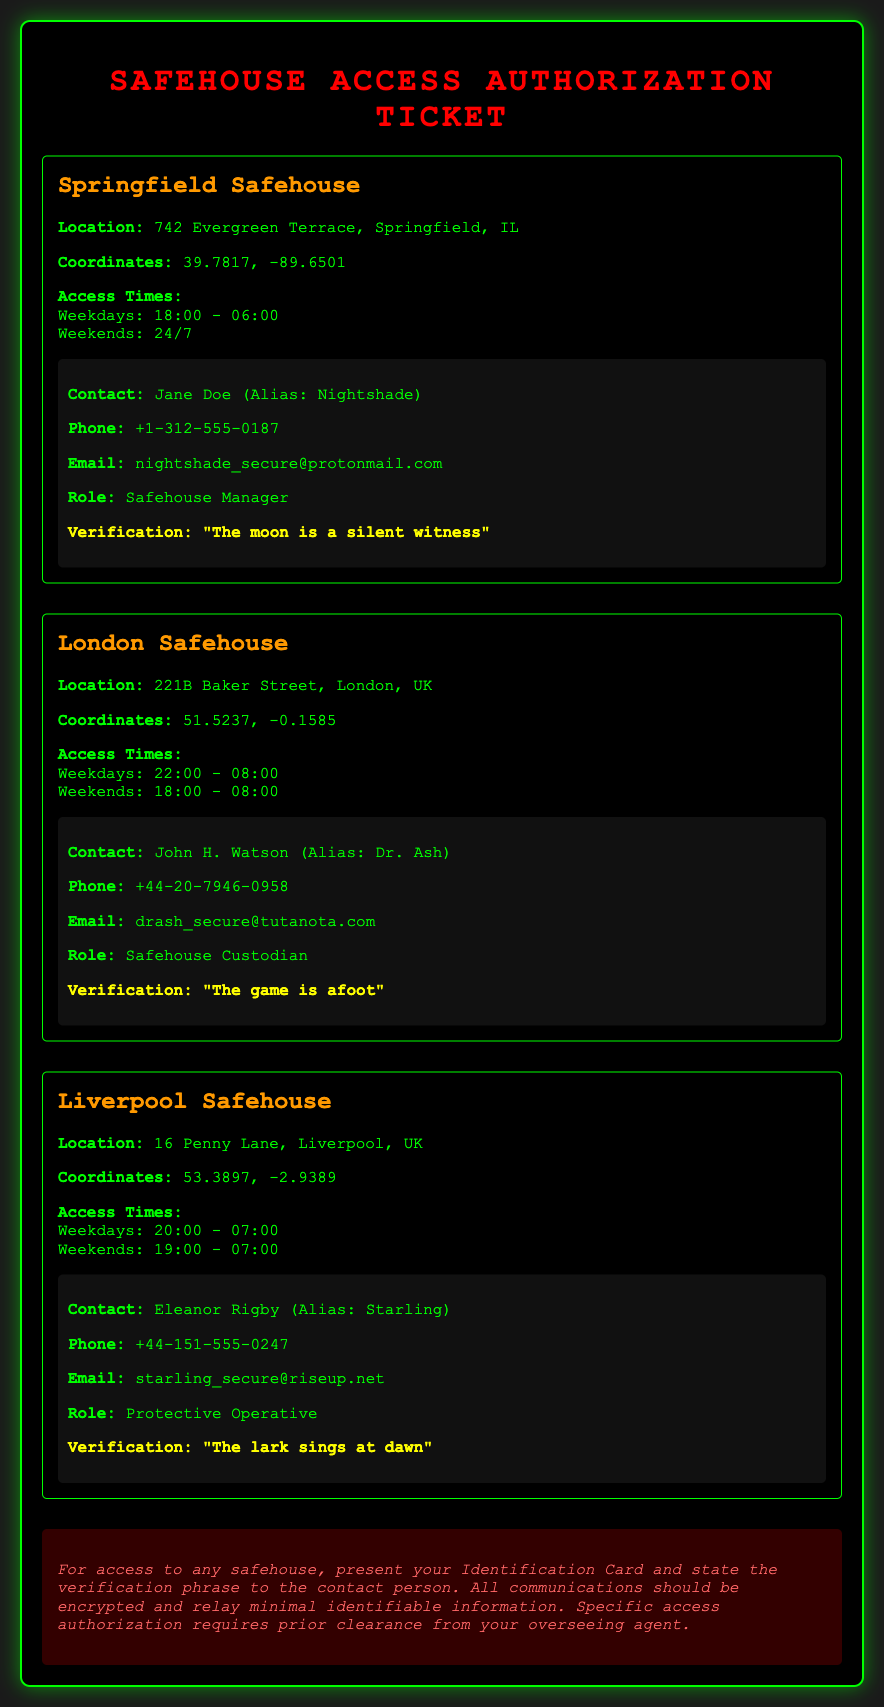What is the location of the Springfield Safehouse? The location of the Springfield Safehouse is specified as 742 Evergreen Terrace, Springfield, IL.
Answer: 742 Evergreen Terrace, Springfield, IL What are the access times for the Liverpool Safehouse on weekends? The access times for the Liverpool Safehouse on weekends are mentioned as 19:00 - 07:00.
Answer: 19:00 - 07:00 Who is the contact person for the London Safehouse? The contact person for the London Safehouse is listed as John H. Watson, also known as Dr. Ash.
Answer: John H. Watson (Alias: Dr. Ash) What is the verification phrase for the Springfield Safehouse? The verification phrase for the Springfield Safehouse is provided as "The moon is a silent witness."
Answer: "The moon is a silent witness" During what hours can you access the Springfield Safehouse on weekdays? The access hours for the Springfield Safehouse on weekdays are stated as 18:00 - 06:00.
Answer: 18:00 - 06:00 How many safehouses are listed in the document? The document lists three safehouses, indicating a count of the distinct locations included.
Answer: Three What role does Jane Doe serve at the Springfield Safehouse? The document specifies that Jane Doe's role is Safehouse Manager.
Answer: Safehouse Manager What should you present to gain access to any safehouse? The instructions indicate that an Identification Card should be presented for access.
Answer: Identification Card What is a prerequisite for specific access authorization? The document mentions that specific access authorization requires prior clearance from your overseeing agent.
Answer: Prior clearance from your overseeing agent 